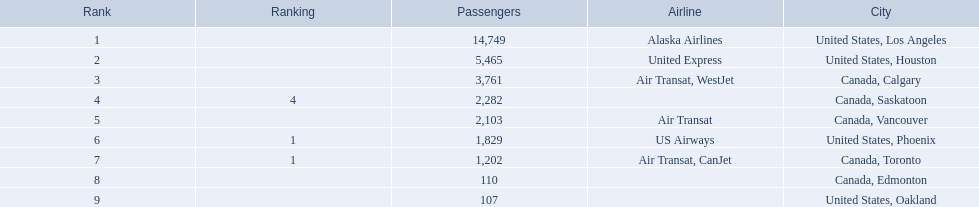Which cities had less than 2,000 passengers? United States, Phoenix, Canada, Toronto, Canada, Edmonton, United States, Oakland. Of these cities, which had fewer than 1,000 passengers? Canada, Edmonton, United States, Oakland. Of the cities in the previous answer, which one had only 107 passengers? United States, Oakland. 